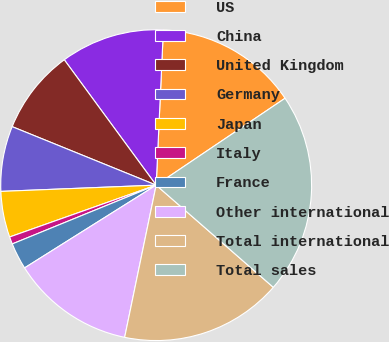Convert chart to OTSL. <chart><loc_0><loc_0><loc_500><loc_500><pie_chart><fcel>US<fcel>China<fcel>United Kingdom<fcel>Germany<fcel>Japan<fcel>Italy<fcel>France<fcel>Other international<fcel>Total international<fcel>Total sales<nl><fcel>14.82%<fcel>10.8%<fcel>8.79%<fcel>6.78%<fcel>4.77%<fcel>0.76%<fcel>2.76%<fcel>12.81%<fcel>16.83%<fcel>20.85%<nl></chart> 